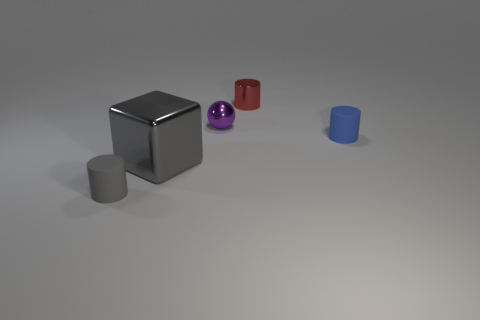What number of rubber objects are gray cylinders or tiny cylinders?
Your answer should be very brief. 2. What is the color of the other matte thing that is the same shape as the small gray thing?
Your answer should be very brief. Blue. What number of small cylinders are the same color as the cube?
Give a very brief answer. 1. There is a object behind the tiny metallic ball; is there a small rubber cylinder that is in front of it?
Your answer should be compact. Yes. What number of objects are both behind the tiny gray rubber object and in front of the tiny red thing?
Make the answer very short. 3. How many large blocks are the same material as the gray cylinder?
Provide a succinct answer. 0. There is a matte cylinder that is right of the tiny rubber thing that is in front of the blue rubber object; how big is it?
Offer a very short reply. Small. Are there any metallic objects of the same shape as the gray rubber object?
Keep it short and to the point. Yes. Does the matte cylinder right of the gray block have the same size as the gray thing in front of the cube?
Offer a terse response. Yes. Are there fewer gray cubes that are on the right side of the big metal thing than small cylinders that are on the right side of the red cylinder?
Provide a succinct answer. Yes. 